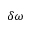<formula> <loc_0><loc_0><loc_500><loc_500>\delta \omega</formula> 